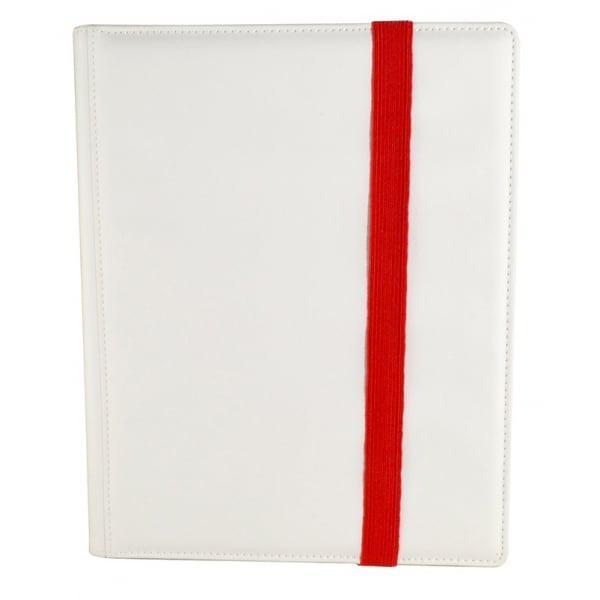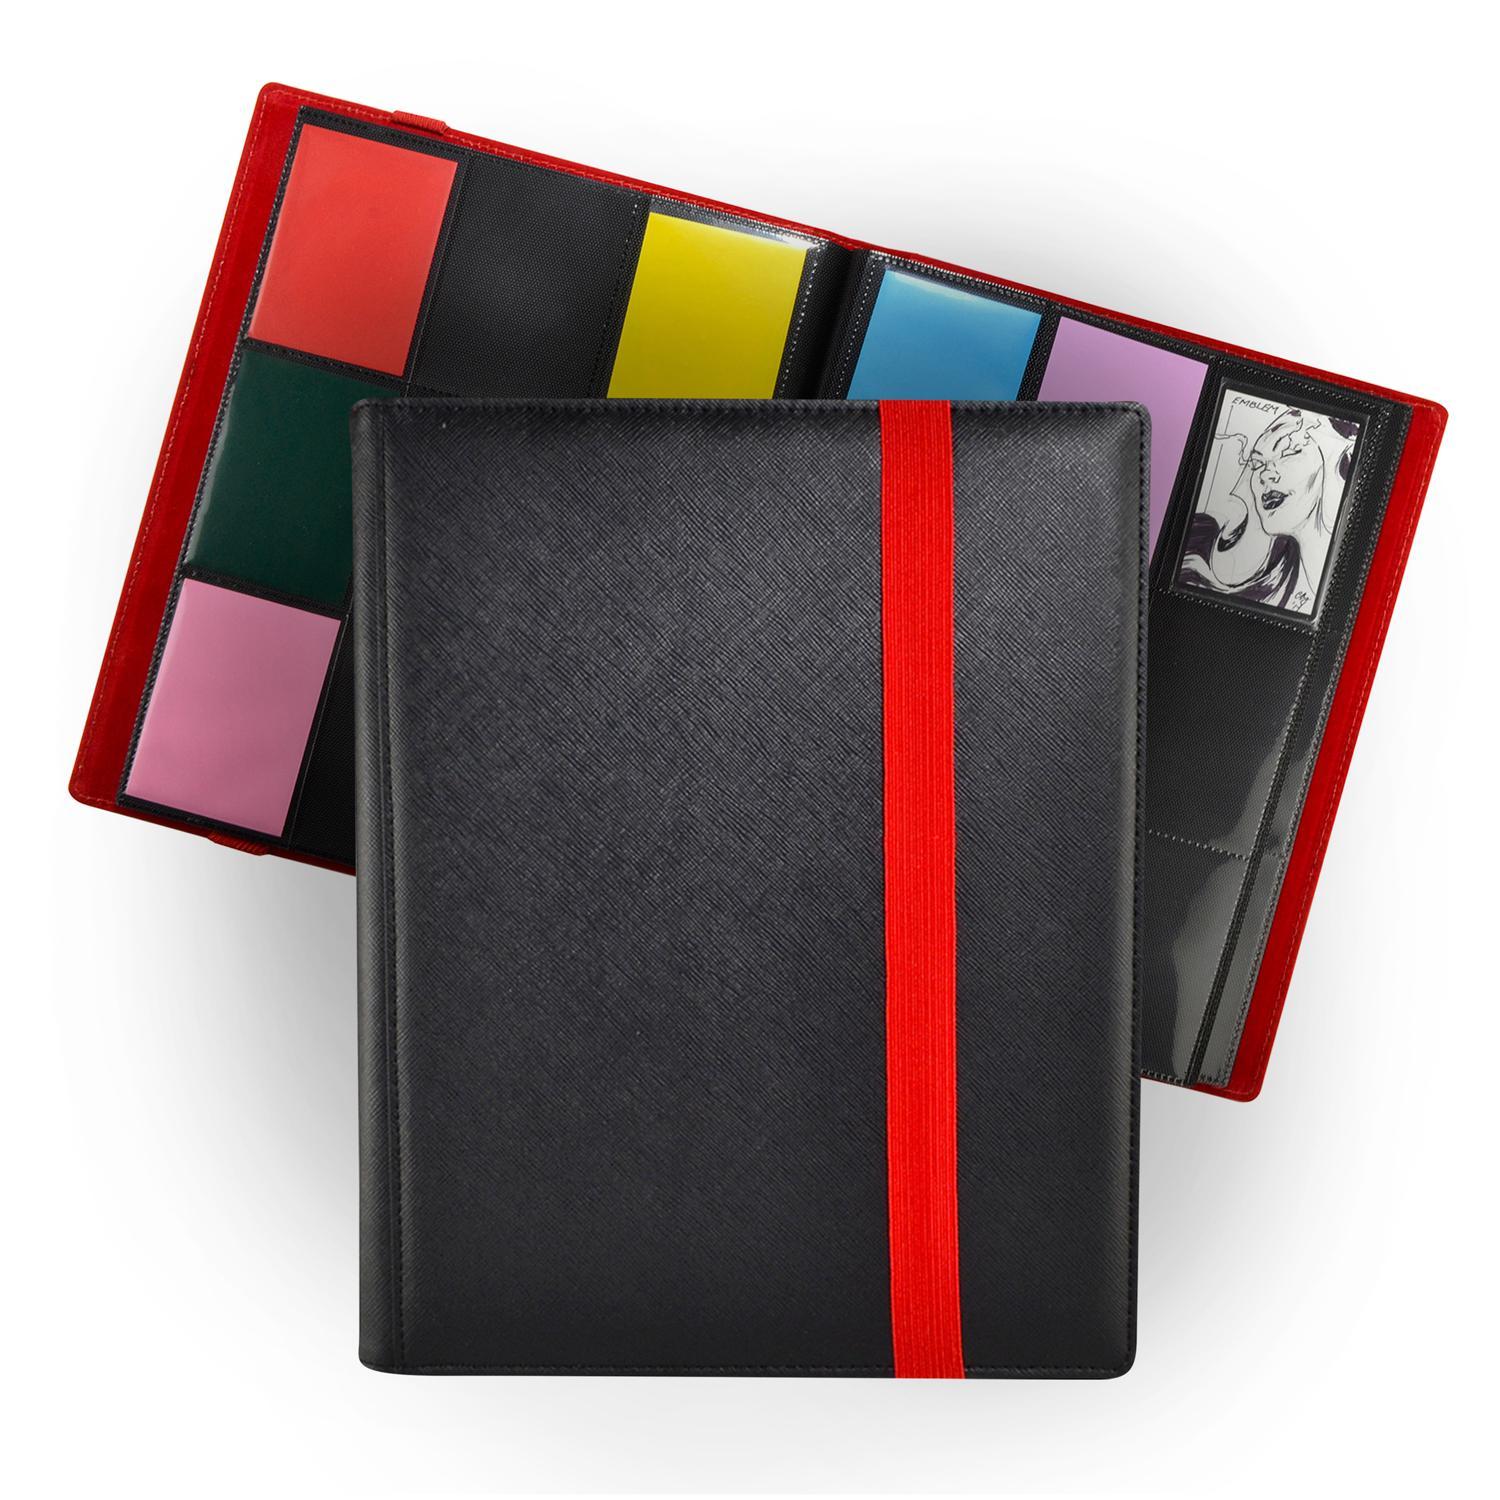The first image is the image on the left, the second image is the image on the right. Assess this claim about the two images: "A set of three tan notebooks is arranged in a standing position.". Correct or not? Answer yes or no. No. 